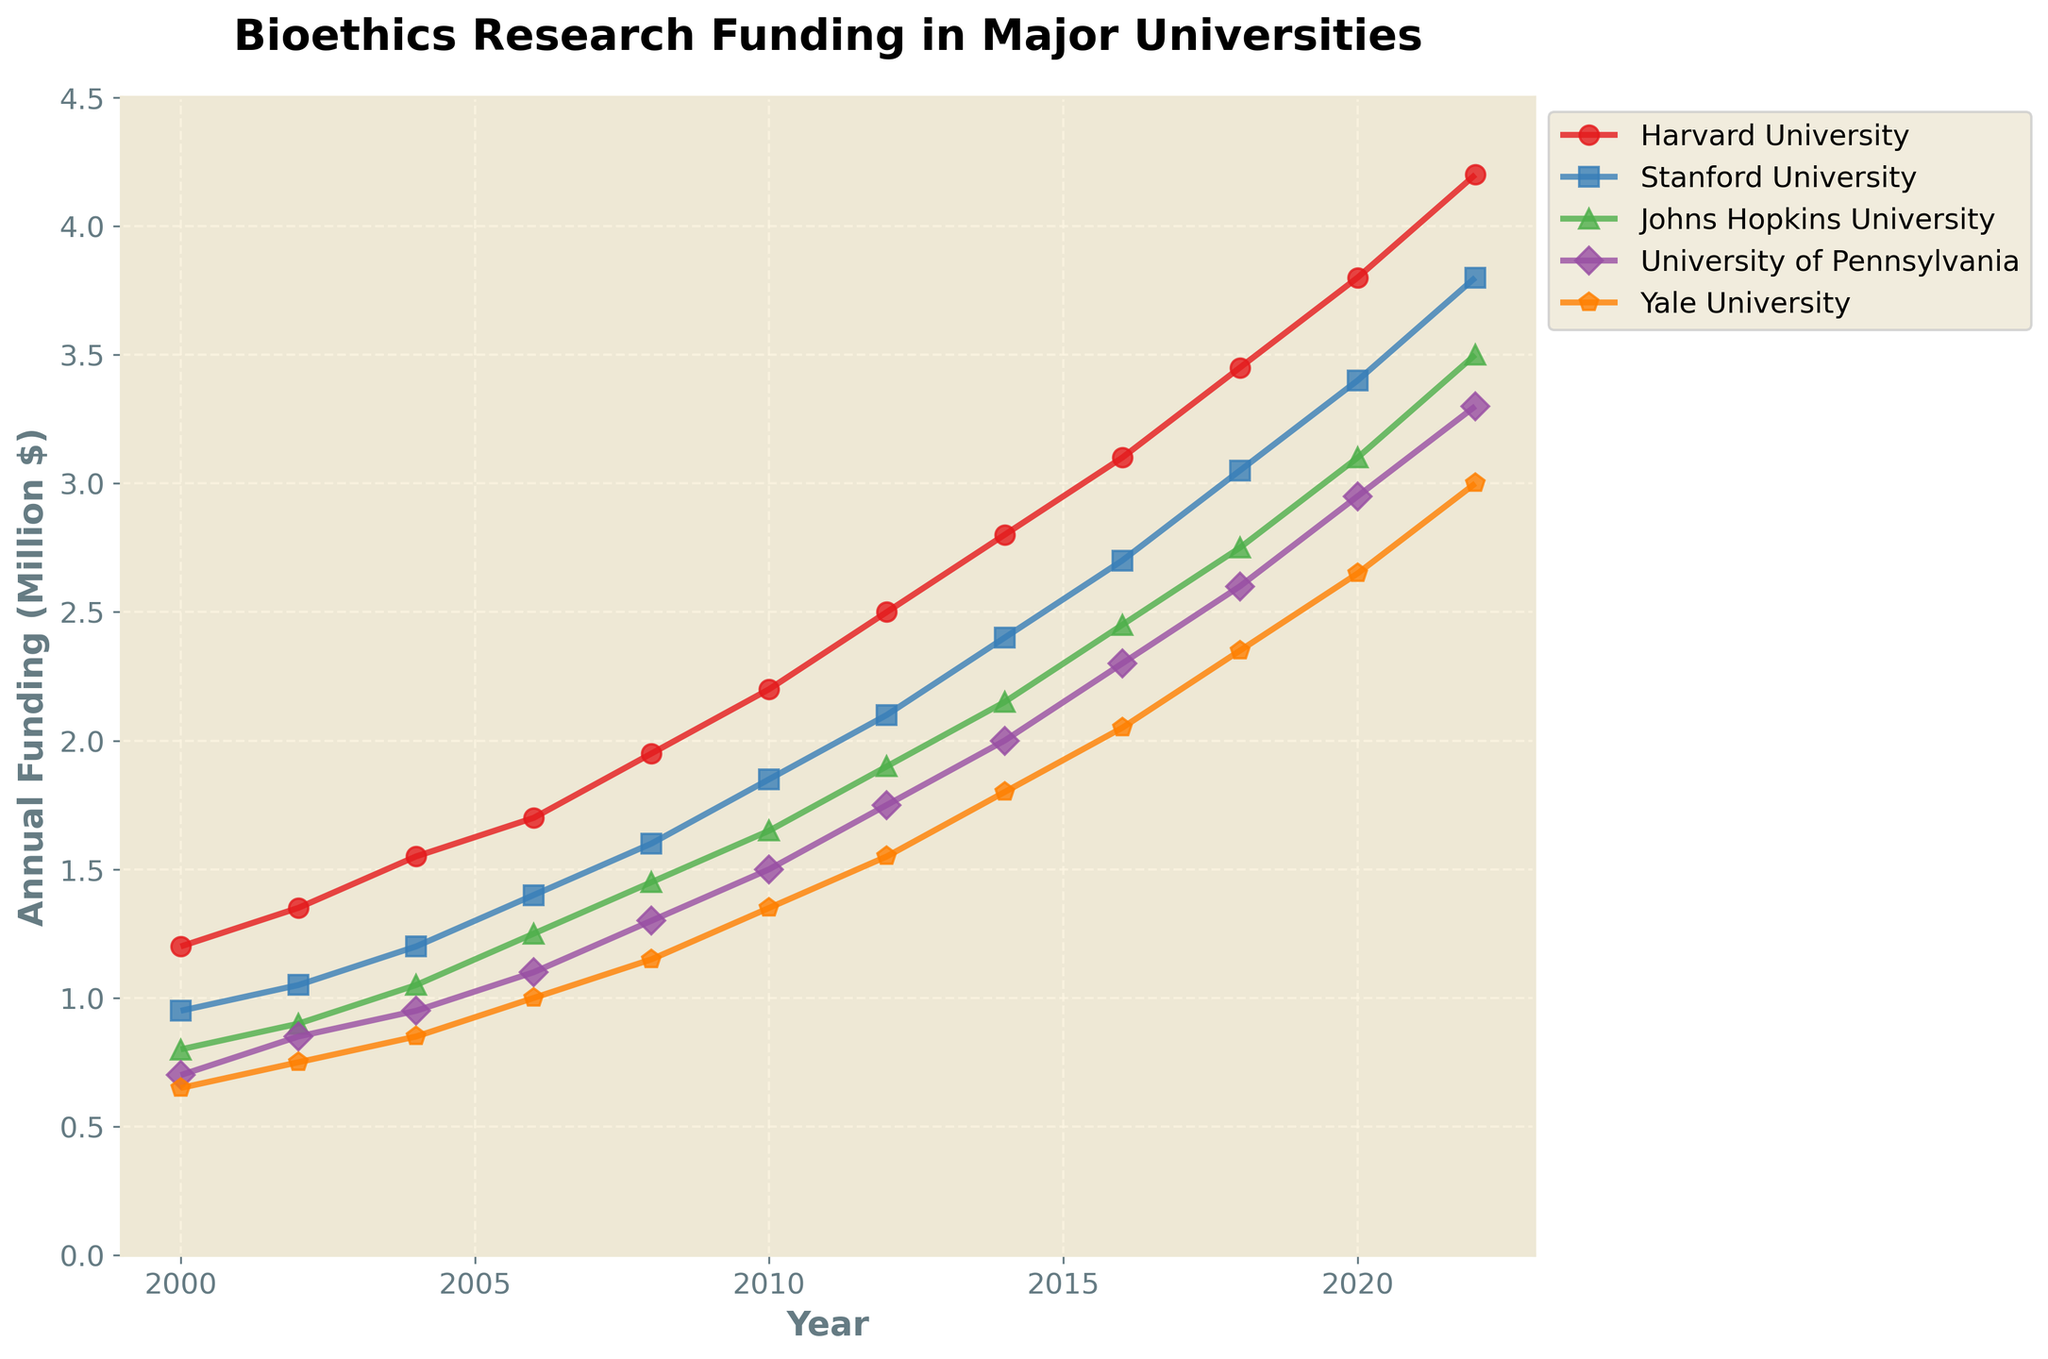What was the trend in bioethics research funding at Harvard University from 2000 to 2022? Observing the line representing Harvard University's funding, it steadily increases from 1.2 million dollars in 2000 to 4.2 million dollars in 2022.
Answer: Steadily increasing Which university received the highest funding in 2022? By looking at the heights of the lines in 2022, Harvard University's line is the highest at 4.2 million dollars.
Answer: Harvard University How did the funding for Stanford University in 2010 compare to that in 2020? Stanford University's funding increased from 1.85 million dollars in 2010 to 3.4 million dollars in 2020.
Answer: Increased What is the average bioethics research funding for Yale University between 2000 and 2022? Summing the funding values for Yale University over the years and dividing by the number of data points: \( (0.65 + 0.75 + 0.85 + 1 + 1.15 + 1.35 + 1.55 + 1.8 + 2.05 + 2.35 + 2.65 + 3.0) \times 10^6 \) gives 18.05 million dollars, which divided by 12 is about 1.5042 million dollars.
Answer: 1.5042 million dollars Compare the funding trends between Johns Hopkins University and University of Pennsylvania from 2000 to 2022. Both universities show increasing trends. John's Hopkins started at 0.8 million and grew to 3.5 million, while University of Pennsylvania began at 0.7 million and grew to 3.3 million over the same period.
Answer: Both increasing By how much did Harvard University's funding grow from 2002 to 2012? The funding grew from 1.35 million dollars in 2002 to 2.5 million dollars in 2012, a difference of: \(2.5 - 1.35 = 1.15\) million dollars.
Answer: 1.15 million dollars Identify the university with the least funding in 2008 and its funding amount. The line at the lowest point in 2008 is for Yale University at 1.15 million dollars.
Answer: Yale University, 1.15 million dollars Which two universities had nearly equal funding in 2018 and what were their funding amounts? Looking at the lines, Johns Hopkins University and University of Pennsylvania in 2018 both have nearly 2.75 million and 2.6 million dollars respectively.
Answer: Johns Hopkins and University of Pennsylvania, 2.75 and 2.6 million dollars 